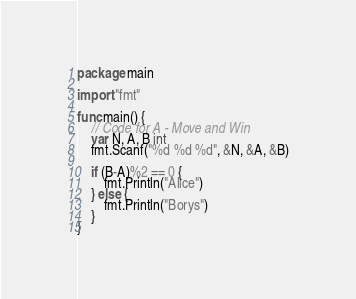<code> <loc_0><loc_0><loc_500><loc_500><_Go_>package main

import "fmt"

func main() {
	// Code for A - Move and Win
	var N, A, B int
	fmt.Scanf("%d %d %d", &N, &A, &B)

	if (B-A)%2 == 0 {
		fmt.Println("Alice")
	} else {
		fmt.Println("Borys")
	}
}
</code> 